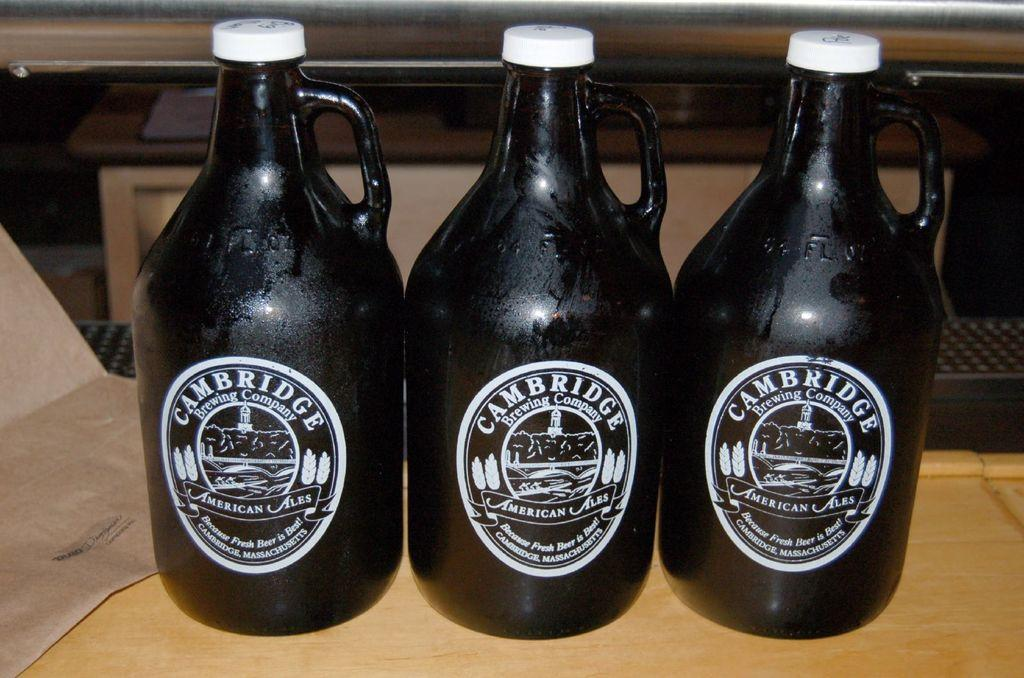Provide a one-sentence caption for the provided image. Three ornate bottles of Cambridge Ale stand side by side. 